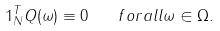<formula> <loc_0><loc_0><loc_500><loc_500>1 _ { N } ^ { T } Q ( \omega ) \equiv 0 \quad f o r a l l \omega \in \Omega .</formula> 